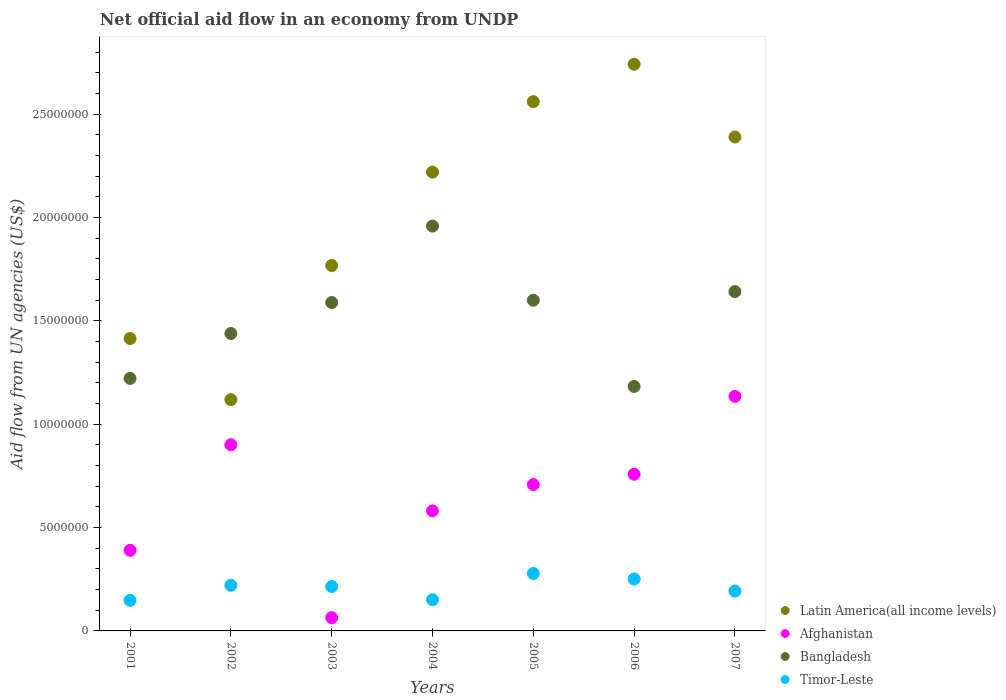What is the net official aid flow in Bangladesh in 2004?
Give a very brief answer. 1.96e+07. Across all years, what is the maximum net official aid flow in Timor-Leste?
Give a very brief answer. 2.78e+06. Across all years, what is the minimum net official aid flow in Latin America(all income levels)?
Your answer should be compact. 1.12e+07. In which year was the net official aid flow in Timor-Leste maximum?
Offer a very short reply. 2005. What is the total net official aid flow in Timor-Leste in the graph?
Provide a succinct answer. 1.46e+07. What is the difference between the net official aid flow in Bangladesh in 2005 and that in 2006?
Keep it short and to the point. 4.17e+06. What is the difference between the net official aid flow in Afghanistan in 2006 and the net official aid flow in Bangladesh in 2004?
Give a very brief answer. -1.20e+07. What is the average net official aid flow in Bangladesh per year?
Offer a very short reply. 1.52e+07. In the year 2006, what is the difference between the net official aid flow in Latin America(all income levels) and net official aid flow in Afghanistan?
Provide a succinct answer. 1.98e+07. In how many years, is the net official aid flow in Bangladesh greater than 21000000 US$?
Your answer should be compact. 0. What is the ratio of the net official aid flow in Afghanistan in 2001 to that in 2003?
Your answer should be very brief. 6.09. What is the difference between the highest and the second highest net official aid flow in Latin America(all income levels)?
Give a very brief answer. 1.81e+06. What is the difference between the highest and the lowest net official aid flow in Afghanistan?
Offer a very short reply. 1.07e+07. In how many years, is the net official aid flow in Timor-Leste greater than the average net official aid flow in Timor-Leste taken over all years?
Give a very brief answer. 4. Is it the case that in every year, the sum of the net official aid flow in Bangladesh and net official aid flow in Timor-Leste  is greater than the sum of net official aid flow in Afghanistan and net official aid flow in Latin America(all income levels)?
Your response must be concise. Yes. Is it the case that in every year, the sum of the net official aid flow in Bangladesh and net official aid flow in Timor-Leste  is greater than the net official aid flow in Afghanistan?
Ensure brevity in your answer.  Yes. Does the net official aid flow in Afghanistan monotonically increase over the years?
Offer a very short reply. No. How many years are there in the graph?
Provide a short and direct response. 7. What is the difference between two consecutive major ticks on the Y-axis?
Your answer should be very brief. 5.00e+06. Are the values on the major ticks of Y-axis written in scientific E-notation?
Provide a succinct answer. No. Where does the legend appear in the graph?
Your response must be concise. Bottom right. What is the title of the graph?
Your answer should be compact. Net official aid flow in an economy from UNDP. What is the label or title of the X-axis?
Make the answer very short. Years. What is the label or title of the Y-axis?
Make the answer very short. Aid flow from UN agencies (US$). What is the Aid flow from UN agencies (US$) of Latin America(all income levels) in 2001?
Ensure brevity in your answer.  1.42e+07. What is the Aid flow from UN agencies (US$) in Afghanistan in 2001?
Provide a short and direct response. 3.90e+06. What is the Aid flow from UN agencies (US$) in Bangladesh in 2001?
Keep it short and to the point. 1.22e+07. What is the Aid flow from UN agencies (US$) in Timor-Leste in 2001?
Offer a terse response. 1.48e+06. What is the Aid flow from UN agencies (US$) in Latin America(all income levels) in 2002?
Your answer should be compact. 1.12e+07. What is the Aid flow from UN agencies (US$) of Afghanistan in 2002?
Ensure brevity in your answer.  9.01e+06. What is the Aid flow from UN agencies (US$) in Bangladesh in 2002?
Your response must be concise. 1.44e+07. What is the Aid flow from UN agencies (US$) of Timor-Leste in 2002?
Ensure brevity in your answer.  2.21e+06. What is the Aid flow from UN agencies (US$) in Latin America(all income levels) in 2003?
Your response must be concise. 1.77e+07. What is the Aid flow from UN agencies (US$) of Afghanistan in 2003?
Give a very brief answer. 6.40e+05. What is the Aid flow from UN agencies (US$) of Bangladesh in 2003?
Provide a short and direct response. 1.59e+07. What is the Aid flow from UN agencies (US$) of Timor-Leste in 2003?
Provide a short and direct response. 2.15e+06. What is the Aid flow from UN agencies (US$) of Latin America(all income levels) in 2004?
Your answer should be very brief. 2.22e+07. What is the Aid flow from UN agencies (US$) in Afghanistan in 2004?
Offer a terse response. 5.81e+06. What is the Aid flow from UN agencies (US$) of Bangladesh in 2004?
Your answer should be very brief. 1.96e+07. What is the Aid flow from UN agencies (US$) in Timor-Leste in 2004?
Give a very brief answer. 1.51e+06. What is the Aid flow from UN agencies (US$) of Latin America(all income levels) in 2005?
Offer a very short reply. 2.56e+07. What is the Aid flow from UN agencies (US$) in Afghanistan in 2005?
Your response must be concise. 7.08e+06. What is the Aid flow from UN agencies (US$) of Bangladesh in 2005?
Provide a short and direct response. 1.60e+07. What is the Aid flow from UN agencies (US$) of Timor-Leste in 2005?
Your answer should be compact. 2.78e+06. What is the Aid flow from UN agencies (US$) of Latin America(all income levels) in 2006?
Offer a terse response. 2.74e+07. What is the Aid flow from UN agencies (US$) in Afghanistan in 2006?
Keep it short and to the point. 7.58e+06. What is the Aid flow from UN agencies (US$) of Bangladesh in 2006?
Make the answer very short. 1.18e+07. What is the Aid flow from UN agencies (US$) in Timor-Leste in 2006?
Your answer should be compact. 2.51e+06. What is the Aid flow from UN agencies (US$) of Latin America(all income levels) in 2007?
Your response must be concise. 2.39e+07. What is the Aid flow from UN agencies (US$) of Afghanistan in 2007?
Your response must be concise. 1.14e+07. What is the Aid flow from UN agencies (US$) in Bangladesh in 2007?
Offer a very short reply. 1.64e+07. What is the Aid flow from UN agencies (US$) in Timor-Leste in 2007?
Make the answer very short. 1.93e+06. Across all years, what is the maximum Aid flow from UN agencies (US$) of Latin America(all income levels)?
Offer a very short reply. 2.74e+07. Across all years, what is the maximum Aid flow from UN agencies (US$) in Afghanistan?
Give a very brief answer. 1.14e+07. Across all years, what is the maximum Aid flow from UN agencies (US$) in Bangladesh?
Make the answer very short. 1.96e+07. Across all years, what is the maximum Aid flow from UN agencies (US$) in Timor-Leste?
Your answer should be very brief. 2.78e+06. Across all years, what is the minimum Aid flow from UN agencies (US$) in Latin America(all income levels)?
Provide a short and direct response. 1.12e+07. Across all years, what is the minimum Aid flow from UN agencies (US$) of Afghanistan?
Your answer should be very brief. 6.40e+05. Across all years, what is the minimum Aid flow from UN agencies (US$) in Bangladesh?
Offer a terse response. 1.18e+07. Across all years, what is the minimum Aid flow from UN agencies (US$) of Timor-Leste?
Give a very brief answer. 1.48e+06. What is the total Aid flow from UN agencies (US$) in Latin America(all income levels) in the graph?
Ensure brevity in your answer.  1.42e+08. What is the total Aid flow from UN agencies (US$) in Afghanistan in the graph?
Make the answer very short. 4.54e+07. What is the total Aid flow from UN agencies (US$) of Bangladesh in the graph?
Your answer should be very brief. 1.06e+08. What is the total Aid flow from UN agencies (US$) in Timor-Leste in the graph?
Your answer should be compact. 1.46e+07. What is the difference between the Aid flow from UN agencies (US$) of Latin America(all income levels) in 2001 and that in 2002?
Ensure brevity in your answer.  2.96e+06. What is the difference between the Aid flow from UN agencies (US$) of Afghanistan in 2001 and that in 2002?
Keep it short and to the point. -5.11e+06. What is the difference between the Aid flow from UN agencies (US$) in Bangladesh in 2001 and that in 2002?
Provide a short and direct response. -2.17e+06. What is the difference between the Aid flow from UN agencies (US$) of Timor-Leste in 2001 and that in 2002?
Provide a short and direct response. -7.30e+05. What is the difference between the Aid flow from UN agencies (US$) of Latin America(all income levels) in 2001 and that in 2003?
Your answer should be very brief. -3.53e+06. What is the difference between the Aid flow from UN agencies (US$) in Afghanistan in 2001 and that in 2003?
Ensure brevity in your answer.  3.26e+06. What is the difference between the Aid flow from UN agencies (US$) in Bangladesh in 2001 and that in 2003?
Offer a terse response. -3.67e+06. What is the difference between the Aid flow from UN agencies (US$) of Timor-Leste in 2001 and that in 2003?
Your answer should be compact. -6.70e+05. What is the difference between the Aid flow from UN agencies (US$) of Latin America(all income levels) in 2001 and that in 2004?
Your response must be concise. -8.05e+06. What is the difference between the Aid flow from UN agencies (US$) in Afghanistan in 2001 and that in 2004?
Provide a succinct answer. -1.91e+06. What is the difference between the Aid flow from UN agencies (US$) in Bangladesh in 2001 and that in 2004?
Your response must be concise. -7.37e+06. What is the difference between the Aid flow from UN agencies (US$) of Latin America(all income levels) in 2001 and that in 2005?
Make the answer very short. -1.15e+07. What is the difference between the Aid flow from UN agencies (US$) in Afghanistan in 2001 and that in 2005?
Make the answer very short. -3.18e+06. What is the difference between the Aid flow from UN agencies (US$) in Bangladesh in 2001 and that in 2005?
Your response must be concise. -3.78e+06. What is the difference between the Aid flow from UN agencies (US$) of Timor-Leste in 2001 and that in 2005?
Provide a succinct answer. -1.30e+06. What is the difference between the Aid flow from UN agencies (US$) in Latin America(all income levels) in 2001 and that in 2006?
Provide a short and direct response. -1.33e+07. What is the difference between the Aid flow from UN agencies (US$) of Afghanistan in 2001 and that in 2006?
Your answer should be compact. -3.68e+06. What is the difference between the Aid flow from UN agencies (US$) of Bangladesh in 2001 and that in 2006?
Offer a terse response. 3.90e+05. What is the difference between the Aid flow from UN agencies (US$) of Timor-Leste in 2001 and that in 2006?
Ensure brevity in your answer.  -1.03e+06. What is the difference between the Aid flow from UN agencies (US$) of Latin America(all income levels) in 2001 and that in 2007?
Your answer should be very brief. -9.75e+06. What is the difference between the Aid flow from UN agencies (US$) in Afghanistan in 2001 and that in 2007?
Provide a succinct answer. -7.45e+06. What is the difference between the Aid flow from UN agencies (US$) of Bangladesh in 2001 and that in 2007?
Ensure brevity in your answer.  -4.20e+06. What is the difference between the Aid flow from UN agencies (US$) in Timor-Leste in 2001 and that in 2007?
Make the answer very short. -4.50e+05. What is the difference between the Aid flow from UN agencies (US$) in Latin America(all income levels) in 2002 and that in 2003?
Make the answer very short. -6.49e+06. What is the difference between the Aid flow from UN agencies (US$) in Afghanistan in 2002 and that in 2003?
Your answer should be very brief. 8.37e+06. What is the difference between the Aid flow from UN agencies (US$) in Bangladesh in 2002 and that in 2003?
Provide a succinct answer. -1.50e+06. What is the difference between the Aid flow from UN agencies (US$) of Timor-Leste in 2002 and that in 2003?
Your response must be concise. 6.00e+04. What is the difference between the Aid flow from UN agencies (US$) in Latin America(all income levels) in 2002 and that in 2004?
Give a very brief answer. -1.10e+07. What is the difference between the Aid flow from UN agencies (US$) in Afghanistan in 2002 and that in 2004?
Offer a very short reply. 3.20e+06. What is the difference between the Aid flow from UN agencies (US$) in Bangladesh in 2002 and that in 2004?
Provide a short and direct response. -5.20e+06. What is the difference between the Aid flow from UN agencies (US$) in Timor-Leste in 2002 and that in 2004?
Keep it short and to the point. 7.00e+05. What is the difference between the Aid flow from UN agencies (US$) in Latin America(all income levels) in 2002 and that in 2005?
Provide a short and direct response. -1.44e+07. What is the difference between the Aid flow from UN agencies (US$) of Afghanistan in 2002 and that in 2005?
Provide a succinct answer. 1.93e+06. What is the difference between the Aid flow from UN agencies (US$) of Bangladesh in 2002 and that in 2005?
Ensure brevity in your answer.  -1.61e+06. What is the difference between the Aid flow from UN agencies (US$) of Timor-Leste in 2002 and that in 2005?
Provide a short and direct response. -5.70e+05. What is the difference between the Aid flow from UN agencies (US$) of Latin America(all income levels) in 2002 and that in 2006?
Make the answer very short. -1.62e+07. What is the difference between the Aid flow from UN agencies (US$) in Afghanistan in 2002 and that in 2006?
Offer a terse response. 1.43e+06. What is the difference between the Aid flow from UN agencies (US$) of Bangladesh in 2002 and that in 2006?
Give a very brief answer. 2.56e+06. What is the difference between the Aid flow from UN agencies (US$) in Timor-Leste in 2002 and that in 2006?
Your answer should be compact. -3.00e+05. What is the difference between the Aid flow from UN agencies (US$) in Latin America(all income levels) in 2002 and that in 2007?
Provide a succinct answer. -1.27e+07. What is the difference between the Aid flow from UN agencies (US$) of Afghanistan in 2002 and that in 2007?
Keep it short and to the point. -2.34e+06. What is the difference between the Aid flow from UN agencies (US$) in Bangladesh in 2002 and that in 2007?
Provide a short and direct response. -2.03e+06. What is the difference between the Aid flow from UN agencies (US$) of Timor-Leste in 2002 and that in 2007?
Give a very brief answer. 2.80e+05. What is the difference between the Aid flow from UN agencies (US$) in Latin America(all income levels) in 2003 and that in 2004?
Provide a short and direct response. -4.52e+06. What is the difference between the Aid flow from UN agencies (US$) of Afghanistan in 2003 and that in 2004?
Offer a terse response. -5.17e+06. What is the difference between the Aid flow from UN agencies (US$) of Bangladesh in 2003 and that in 2004?
Your response must be concise. -3.70e+06. What is the difference between the Aid flow from UN agencies (US$) in Timor-Leste in 2003 and that in 2004?
Give a very brief answer. 6.40e+05. What is the difference between the Aid flow from UN agencies (US$) in Latin America(all income levels) in 2003 and that in 2005?
Offer a very short reply. -7.93e+06. What is the difference between the Aid flow from UN agencies (US$) of Afghanistan in 2003 and that in 2005?
Your answer should be compact. -6.44e+06. What is the difference between the Aid flow from UN agencies (US$) in Timor-Leste in 2003 and that in 2005?
Your answer should be compact. -6.30e+05. What is the difference between the Aid flow from UN agencies (US$) in Latin America(all income levels) in 2003 and that in 2006?
Give a very brief answer. -9.74e+06. What is the difference between the Aid flow from UN agencies (US$) in Afghanistan in 2003 and that in 2006?
Your answer should be compact. -6.94e+06. What is the difference between the Aid flow from UN agencies (US$) of Bangladesh in 2003 and that in 2006?
Provide a short and direct response. 4.06e+06. What is the difference between the Aid flow from UN agencies (US$) in Timor-Leste in 2003 and that in 2006?
Offer a terse response. -3.60e+05. What is the difference between the Aid flow from UN agencies (US$) of Latin America(all income levels) in 2003 and that in 2007?
Provide a succinct answer. -6.22e+06. What is the difference between the Aid flow from UN agencies (US$) in Afghanistan in 2003 and that in 2007?
Ensure brevity in your answer.  -1.07e+07. What is the difference between the Aid flow from UN agencies (US$) of Bangladesh in 2003 and that in 2007?
Provide a succinct answer. -5.30e+05. What is the difference between the Aid flow from UN agencies (US$) in Timor-Leste in 2003 and that in 2007?
Provide a short and direct response. 2.20e+05. What is the difference between the Aid flow from UN agencies (US$) of Latin America(all income levels) in 2004 and that in 2005?
Your answer should be compact. -3.41e+06. What is the difference between the Aid flow from UN agencies (US$) in Afghanistan in 2004 and that in 2005?
Provide a succinct answer. -1.27e+06. What is the difference between the Aid flow from UN agencies (US$) in Bangladesh in 2004 and that in 2005?
Give a very brief answer. 3.59e+06. What is the difference between the Aid flow from UN agencies (US$) in Timor-Leste in 2004 and that in 2005?
Keep it short and to the point. -1.27e+06. What is the difference between the Aid flow from UN agencies (US$) in Latin America(all income levels) in 2004 and that in 2006?
Ensure brevity in your answer.  -5.22e+06. What is the difference between the Aid flow from UN agencies (US$) of Afghanistan in 2004 and that in 2006?
Ensure brevity in your answer.  -1.77e+06. What is the difference between the Aid flow from UN agencies (US$) in Bangladesh in 2004 and that in 2006?
Your answer should be very brief. 7.76e+06. What is the difference between the Aid flow from UN agencies (US$) of Latin America(all income levels) in 2004 and that in 2007?
Give a very brief answer. -1.70e+06. What is the difference between the Aid flow from UN agencies (US$) in Afghanistan in 2004 and that in 2007?
Provide a succinct answer. -5.54e+06. What is the difference between the Aid flow from UN agencies (US$) of Bangladesh in 2004 and that in 2007?
Your answer should be very brief. 3.17e+06. What is the difference between the Aid flow from UN agencies (US$) in Timor-Leste in 2004 and that in 2007?
Give a very brief answer. -4.20e+05. What is the difference between the Aid flow from UN agencies (US$) in Latin America(all income levels) in 2005 and that in 2006?
Your answer should be very brief. -1.81e+06. What is the difference between the Aid flow from UN agencies (US$) in Afghanistan in 2005 and that in 2006?
Your response must be concise. -5.00e+05. What is the difference between the Aid flow from UN agencies (US$) in Bangladesh in 2005 and that in 2006?
Provide a succinct answer. 4.17e+06. What is the difference between the Aid flow from UN agencies (US$) of Timor-Leste in 2005 and that in 2006?
Your answer should be very brief. 2.70e+05. What is the difference between the Aid flow from UN agencies (US$) in Latin America(all income levels) in 2005 and that in 2007?
Your response must be concise. 1.71e+06. What is the difference between the Aid flow from UN agencies (US$) in Afghanistan in 2005 and that in 2007?
Offer a very short reply. -4.27e+06. What is the difference between the Aid flow from UN agencies (US$) of Bangladesh in 2005 and that in 2007?
Ensure brevity in your answer.  -4.20e+05. What is the difference between the Aid flow from UN agencies (US$) of Timor-Leste in 2005 and that in 2007?
Make the answer very short. 8.50e+05. What is the difference between the Aid flow from UN agencies (US$) in Latin America(all income levels) in 2006 and that in 2007?
Offer a very short reply. 3.52e+06. What is the difference between the Aid flow from UN agencies (US$) of Afghanistan in 2006 and that in 2007?
Your answer should be compact. -3.77e+06. What is the difference between the Aid flow from UN agencies (US$) in Bangladesh in 2006 and that in 2007?
Give a very brief answer. -4.59e+06. What is the difference between the Aid flow from UN agencies (US$) of Timor-Leste in 2006 and that in 2007?
Ensure brevity in your answer.  5.80e+05. What is the difference between the Aid flow from UN agencies (US$) in Latin America(all income levels) in 2001 and the Aid flow from UN agencies (US$) in Afghanistan in 2002?
Your answer should be very brief. 5.14e+06. What is the difference between the Aid flow from UN agencies (US$) in Latin America(all income levels) in 2001 and the Aid flow from UN agencies (US$) in Timor-Leste in 2002?
Your answer should be compact. 1.19e+07. What is the difference between the Aid flow from UN agencies (US$) of Afghanistan in 2001 and the Aid flow from UN agencies (US$) of Bangladesh in 2002?
Ensure brevity in your answer.  -1.05e+07. What is the difference between the Aid flow from UN agencies (US$) of Afghanistan in 2001 and the Aid flow from UN agencies (US$) of Timor-Leste in 2002?
Your answer should be very brief. 1.69e+06. What is the difference between the Aid flow from UN agencies (US$) of Bangladesh in 2001 and the Aid flow from UN agencies (US$) of Timor-Leste in 2002?
Your answer should be very brief. 1.00e+07. What is the difference between the Aid flow from UN agencies (US$) in Latin America(all income levels) in 2001 and the Aid flow from UN agencies (US$) in Afghanistan in 2003?
Keep it short and to the point. 1.35e+07. What is the difference between the Aid flow from UN agencies (US$) in Latin America(all income levels) in 2001 and the Aid flow from UN agencies (US$) in Bangladesh in 2003?
Offer a terse response. -1.74e+06. What is the difference between the Aid flow from UN agencies (US$) in Latin America(all income levels) in 2001 and the Aid flow from UN agencies (US$) in Timor-Leste in 2003?
Provide a short and direct response. 1.20e+07. What is the difference between the Aid flow from UN agencies (US$) in Afghanistan in 2001 and the Aid flow from UN agencies (US$) in Bangladesh in 2003?
Provide a succinct answer. -1.20e+07. What is the difference between the Aid flow from UN agencies (US$) in Afghanistan in 2001 and the Aid flow from UN agencies (US$) in Timor-Leste in 2003?
Your answer should be compact. 1.75e+06. What is the difference between the Aid flow from UN agencies (US$) in Bangladesh in 2001 and the Aid flow from UN agencies (US$) in Timor-Leste in 2003?
Your response must be concise. 1.01e+07. What is the difference between the Aid flow from UN agencies (US$) in Latin America(all income levels) in 2001 and the Aid flow from UN agencies (US$) in Afghanistan in 2004?
Provide a short and direct response. 8.34e+06. What is the difference between the Aid flow from UN agencies (US$) in Latin America(all income levels) in 2001 and the Aid flow from UN agencies (US$) in Bangladesh in 2004?
Offer a terse response. -5.44e+06. What is the difference between the Aid flow from UN agencies (US$) in Latin America(all income levels) in 2001 and the Aid flow from UN agencies (US$) in Timor-Leste in 2004?
Provide a short and direct response. 1.26e+07. What is the difference between the Aid flow from UN agencies (US$) of Afghanistan in 2001 and the Aid flow from UN agencies (US$) of Bangladesh in 2004?
Your answer should be compact. -1.57e+07. What is the difference between the Aid flow from UN agencies (US$) in Afghanistan in 2001 and the Aid flow from UN agencies (US$) in Timor-Leste in 2004?
Your answer should be very brief. 2.39e+06. What is the difference between the Aid flow from UN agencies (US$) of Bangladesh in 2001 and the Aid flow from UN agencies (US$) of Timor-Leste in 2004?
Your answer should be very brief. 1.07e+07. What is the difference between the Aid flow from UN agencies (US$) in Latin America(all income levels) in 2001 and the Aid flow from UN agencies (US$) in Afghanistan in 2005?
Your response must be concise. 7.07e+06. What is the difference between the Aid flow from UN agencies (US$) of Latin America(all income levels) in 2001 and the Aid flow from UN agencies (US$) of Bangladesh in 2005?
Your answer should be very brief. -1.85e+06. What is the difference between the Aid flow from UN agencies (US$) in Latin America(all income levels) in 2001 and the Aid flow from UN agencies (US$) in Timor-Leste in 2005?
Your answer should be compact. 1.14e+07. What is the difference between the Aid flow from UN agencies (US$) of Afghanistan in 2001 and the Aid flow from UN agencies (US$) of Bangladesh in 2005?
Your answer should be compact. -1.21e+07. What is the difference between the Aid flow from UN agencies (US$) in Afghanistan in 2001 and the Aid flow from UN agencies (US$) in Timor-Leste in 2005?
Keep it short and to the point. 1.12e+06. What is the difference between the Aid flow from UN agencies (US$) of Bangladesh in 2001 and the Aid flow from UN agencies (US$) of Timor-Leste in 2005?
Provide a short and direct response. 9.44e+06. What is the difference between the Aid flow from UN agencies (US$) of Latin America(all income levels) in 2001 and the Aid flow from UN agencies (US$) of Afghanistan in 2006?
Ensure brevity in your answer.  6.57e+06. What is the difference between the Aid flow from UN agencies (US$) of Latin America(all income levels) in 2001 and the Aid flow from UN agencies (US$) of Bangladesh in 2006?
Your answer should be compact. 2.32e+06. What is the difference between the Aid flow from UN agencies (US$) of Latin America(all income levels) in 2001 and the Aid flow from UN agencies (US$) of Timor-Leste in 2006?
Ensure brevity in your answer.  1.16e+07. What is the difference between the Aid flow from UN agencies (US$) of Afghanistan in 2001 and the Aid flow from UN agencies (US$) of Bangladesh in 2006?
Provide a short and direct response. -7.93e+06. What is the difference between the Aid flow from UN agencies (US$) of Afghanistan in 2001 and the Aid flow from UN agencies (US$) of Timor-Leste in 2006?
Your answer should be very brief. 1.39e+06. What is the difference between the Aid flow from UN agencies (US$) of Bangladesh in 2001 and the Aid flow from UN agencies (US$) of Timor-Leste in 2006?
Provide a succinct answer. 9.71e+06. What is the difference between the Aid flow from UN agencies (US$) in Latin America(all income levels) in 2001 and the Aid flow from UN agencies (US$) in Afghanistan in 2007?
Provide a succinct answer. 2.80e+06. What is the difference between the Aid flow from UN agencies (US$) of Latin America(all income levels) in 2001 and the Aid flow from UN agencies (US$) of Bangladesh in 2007?
Your answer should be compact. -2.27e+06. What is the difference between the Aid flow from UN agencies (US$) in Latin America(all income levels) in 2001 and the Aid flow from UN agencies (US$) in Timor-Leste in 2007?
Keep it short and to the point. 1.22e+07. What is the difference between the Aid flow from UN agencies (US$) of Afghanistan in 2001 and the Aid flow from UN agencies (US$) of Bangladesh in 2007?
Keep it short and to the point. -1.25e+07. What is the difference between the Aid flow from UN agencies (US$) of Afghanistan in 2001 and the Aid flow from UN agencies (US$) of Timor-Leste in 2007?
Your response must be concise. 1.97e+06. What is the difference between the Aid flow from UN agencies (US$) in Bangladesh in 2001 and the Aid flow from UN agencies (US$) in Timor-Leste in 2007?
Ensure brevity in your answer.  1.03e+07. What is the difference between the Aid flow from UN agencies (US$) in Latin America(all income levels) in 2002 and the Aid flow from UN agencies (US$) in Afghanistan in 2003?
Offer a terse response. 1.06e+07. What is the difference between the Aid flow from UN agencies (US$) of Latin America(all income levels) in 2002 and the Aid flow from UN agencies (US$) of Bangladesh in 2003?
Ensure brevity in your answer.  -4.70e+06. What is the difference between the Aid flow from UN agencies (US$) in Latin America(all income levels) in 2002 and the Aid flow from UN agencies (US$) in Timor-Leste in 2003?
Give a very brief answer. 9.04e+06. What is the difference between the Aid flow from UN agencies (US$) of Afghanistan in 2002 and the Aid flow from UN agencies (US$) of Bangladesh in 2003?
Keep it short and to the point. -6.88e+06. What is the difference between the Aid flow from UN agencies (US$) in Afghanistan in 2002 and the Aid flow from UN agencies (US$) in Timor-Leste in 2003?
Your answer should be compact. 6.86e+06. What is the difference between the Aid flow from UN agencies (US$) in Bangladesh in 2002 and the Aid flow from UN agencies (US$) in Timor-Leste in 2003?
Ensure brevity in your answer.  1.22e+07. What is the difference between the Aid flow from UN agencies (US$) of Latin America(all income levels) in 2002 and the Aid flow from UN agencies (US$) of Afghanistan in 2004?
Provide a succinct answer. 5.38e+06. What is the difference between the Aid flow from UN agencies (US$) in Latin America(all income levels) in 2002 and the Aid flow from UN agencies (US$) in Bangladesh in 2004?
Keep it short and to the point. -8.40e+06. What is the difference between the Aid flow from UN agencies (US$) of Latin America(all income levels) in 2002 and the Aid flow from UN agencies (US$) of Timor-Leste in 2004?
Make the answer very short. 9.68e+06. What is the difference between the Aid flow from UN agencies (US$) of Afghanistan in 2002 and the Aid flow from UN agencies (US$) of Bangladesh in 2004?
Ensure brevity in your answer.  -1.06e+07. What is the difference between the Aid flow from UN agencies (US$) of Afghanistan in 2002 and the Aid flow from UN agencies (US$) of Timor-Leste in 2004?
Offer a very short reply. 7.50e+06. What is the difference between the Aid flow from UN agencies (US$) in Bangladesh in 2002 and the Aid flow from UN agencies (US$) in Timor-Leste in 2004?
Ensure brevity in your answer.  1.29e+07. What is the difference between the Aid flow from UN agencies (US$) of Latin America(all income levels) in 2002 and the Aid flow from UN agencies (US$) of Afghanistan in 2005?
Ensure brevity in your answer.  4.11e+06. What is the difference between the Aid flow from UN agencies (US$) of Latin America(all income levels) in 2002 and the Aid flow from UN agencies (US$) of Bangladesh in 2005?
Provide a succinct answer. -4.81e+06. What is the difference between the Aid flow from UN agencies (US$) of Latin America(all income levels) in 2002 and the Aid flow from UN agencies (US$) of Timor-Leste in 2005?
Give a very brief answer. 8.41e+06. What is the difference between the Aid flow from UN agencies (US$) in Afghanistan in 2002 and the Aid flow from UN agencies (US$) in Bangladesh in 2005?
Your answer should be very brief. -6.99e+06. What is the difference between the Aid flow from UN agencies (US$) of Afghanistan in 2002 and the Aid flow from UN agencies (US$) of Timor-Leste in 2005?
Offer a very short reply. 6.23e+06. What is the difference between the Aid flow from UN agencies (US$) in Bangladesh in 2002 and the Aid flow from UN agencies (US$) in Timor-Leste in 2005?
Provide a short and direct response. 1.16e+07. What is the difference between the Aid flow from UN agencies (US$) in Latin America(all income levels) in 2002 and the Aid flow from UN agencies (US$) in Afghanistan in 2006?
Your answer should be very brief. 3.61e+06. What is the difference between the Aid flow from UN agencies (US$) in Latin America(all income levels) in 2002 and the Aid flow from UN agencies (US$) in Bangladesh in 2006?
Provide a short and direct response. -6.40e+05. What is the difference between the Aid flow from UN agencies (US$) in Latin America(all income levels) in 2002 and the Aid flow from UN agencies (US$) in Timor-Leste in 2006?
Your answer should be very brief. 8.68e+06. What is the difference between the Aid flow from UN agencies (US$) in Afghanistan in 2002 and the Aid flow from UN agencies (US$) in Bangladesh in 2006?
Give a very brief answer. -2.82e+06. What is the difference between the Aid flow from UN agencies (US$) of Afghanistan in 2002 and the Aid flow from UN agencies (US$) of Timor-Leste in 2006?
Your answer should be compact. 6.50e+06. What is the difference between the Aid flow from UN agencies (US$) of Bangladesh in 2002 and the Aid flow from UN agencies (US$) of Timor-Leste in 2006?
Offer a very short reply. 1.19e+07. What is the difference between the Aid flow from UN agencies (US$) of Latin America(all income levels) in 2002 and the Aid flow from UN agencies (US$) of Bangladesh in 2007?
Keep it short and to the point. -5.23e+06. What is the difference between the Aid flow from UN agencies (US$) of Latin America(all income levels) in 2002 and the Aid flow from UN agencies (US$) of Timor-Leste in 2007?
Provide a succinct answer. 9.26e+06. What is the difference between the Aid flow from UN agencies (US$) in Afghanistan in 2002 and the Aid flow from UN agencies (US$) in Bangladesh in 2007?
Provide a succinct answer. -7.41e+06. What is the difference between the Aid flow from UN agencies (US$) of Afghanistan in 2002 and the Aid flow from UN agencies (US$) of Timor-Leste in 2007?
Offer a terse response. 7.08e+06. What is the difference between the Aid flow from UN agencies (US$) of Bangladesh in 2002 and the Aid flow from UN agencies (US$) of Timor-Leste in 2007?
Your response must be concise. 1.25e+07. What is the difference between the Aid flow from UN agencies (US$) of Latin America(all income levels) in 2003 and the Aid flow from UN agencies (US$) of Afghanistan in 2004?
Make the answer very short. 1.19e+07. What is the difference between the Aid flow from UN agencies (US$) of Latin America(all income levels) in 2003 and the Aid flow from UN agencies (US$) of Bangladesh in 2004?
Offer a terse response. -1.91e+06. What is the difference between the Aid flow from UN agencies (US$) of Latin America(all income levels) in 2003 and the Aid flow from UN agencies (US$) of Timor-Leste in 2004?
Provide a succinct answer. 1.62e+07. What is the difference between the Aid flow from UN agencies (US$) in Afghanistan in 2003 and the Aid flow from UN agencies (US$) in Bangladesh in 2004?
Your answer should be very brief. -1.90e+07. What is the difference between the Aid flow from UN agencies (US$) of Afghanistan in 2003 and the Aid flow from UN agencies (US$) of Timor-Leste in 2004?
Make the answer very short. -8.70e+05. What is the difference between the Aid flow from UN agencies (US$) in Bangladesh in 2003 and the Aid flow from UN agencies (US$) in Timor-Leste in 2004?
Offer a very short reply. 1.44e+07. What is the difference between the Aid flow from UN agencies (US$) in Latin America(all income levels) in 2003 and the Aid flow from UN agencies (US$) in Afghanistan in 2005?
Offer a terse response. 1.06e+07. What is the difference between the Aid flow from UN agencies (US$) in Latin America(all income levels) in 2003 and the Aid flow from UN agencies (US$) in Bangladesh in 2005?
Make the answer very short. 1.68e+06. What is the difference between the Aid flow from UN agencies (US$) of Latin America(all income levels) in 2003 and the Aid flow from UN agencies (US$) of Timor-Leste in 2005?
Your answer should be compact. 1.49e+07. What is the difference between the Aid flow from UN agencies (US$) of Afghanistan in 2003 and the Aid flow from UN agencies (US$) of Bangladesh in 2005?
Offer a terse response. -1.54e+07. What is the difference between the Aid flow from UN agencies (US$) in Afghanistan in 2003 and the Aid flow from UN agencies (US$) in Timor-Leste in 2005?
Provide a succinct answer. -2.14e+06. What is the difference between the Aid flow from UN agencies (US$) of Bangladesh in 2003 and the Aid flow from UN agencies (US$) of Timor-Leste in 2005?
Provide a succinct answer. 1.31e+07. What is the difference between the Aid flow from UN agencies (US$) in Latin America(all income levels) in 2003 and the Aid flow from UN agencies (US$) in Afghanistan in 2006?
Offer a very short reply. 1.01e+07. What is the difference between the Aid flow from UN agencies (US$) in Latin America(all income levels) in 2003 and the Aid flow from UN agencies (US$) in Bangladesh in 2006?
Make the answer very short. 5.85e+06. What is the difference between the Aid flow from UN agencies (US$) of Latin America(all income levels) in 2003 and the Aid flow from UN agencies (US$) of Timor-Leste in 2006?
Ensure brevity in your answer.  1.52e+07. What is the difference between the Aid flow from UN agencies (US$) of Afghanistan in 2003 and the Aid flow from UN agencies (US$) of Bangladesh in 2006?
Keep it short and to the point. -1.12e+07. What is the difference between the Aid flow from UN agencies (US$) in Afghanistan in 2003 and the Aid flow from UN agencies (US$) in Timor-Leste in 2006?
Ensure brevity in your answer.  -1.87e+06. What is the difference between the Aid flow from UN agencies (US$) in Bangladesh in 2003 and the Aid flow from UN agencies (US$) in Timor-Leste in 2006?
Your answer should be compact. 1.34e+07. What is the difference between the Aid flow from UN agencies (US$) in Latin America(all income levels) in 2003 and the Aid flow from UN agencies (US$) in Afghanistan in 2007?
Provide a succinct answer. 6.33e+06. What is the difference between the Aid flow from UN agencies (US$) in Latin America(all income levels) in 2003 and the Aid flow from UN agencies (US$) in Bangladesh in 2007?
Provide a short and direct response. 1.26e+06. What is the difference between the Aid flow from UN agencies (US$) in Latin America(all income levels) in 2003 and the Aid flow from UN agencies (US$) in Timor-Leste in 2007?
Provide a short and direct response. 1.58e+07. What is the difference between the Aid flow from UN agencies (US$) in Afghanistan in 2003 and the Aid flow from UN agencies (US$) in Bangladesh in 2007?
Provide a short and direct response. -1.58e+07. What is the difference between the Aid flow from UN agencies (US$) of Afghanistan in 2003 and the Aid flow from UN agencies (US$) of Timor-Leste in 2007?
Make the answer very short. -1.29e+06. What is the difference between the Aid flow from UN agencies (US$) of Bangladesh in 2003 and the Aid flow from UN agencies (US$) of Timor-Leste in 2007?
Offer a terse response. 1.40e+07. What is the difference between the Aid flow from UN agencies (US$) of Latin America(all income levels) in 2004 and the Aid flow from UN agencies (US$) of Afghanistan in 2005?
Offer a very short reply. 1.51e+07. What is the difference between the Aid flow from UN agencies (US$) of Latin America(all income levels) in 2004 and the Aid flow from UN agencies (US$) of Bangladesh in 2005?
Your response must be concise. 6.20e+06. What is the difference between the Aid flow from UN agencies (US$) in Latin America(all income levels) in 2004 and the Aid flow from UN agencies (US$) in Timor-Leste in 2005?
Your response must be concise. 1.94e+07. What is the difference between the Aid flow from UN agencies (US$) of Afghanistan in 2004 and the Aid flow from UN agencies (US$) of Bangladesh in 2005?
Make the answer very short. -1.02e+07. What is the difference between the Aid flow from UN agencies (US$) in Afghanistan in 2004 and the Aid flow from UN agencies (US$) in Timor-Leste in 2005?
Your answer should be compact. 3.03e+06. What is the difference between the Aid flow from UN agencies (US$) of Bangladesh in 2004 and the Aid flow from UN agencies (US$) of Timor-Leste in 2005?
Offer a very short reply. 1.68e+07. What is the difference between the Aid flow from UN agencies (US$) in Latin America(all income levels) in 2004 and the Aid flow from UN agencies (US$) in Afghanistan in 2006?
Your response must be concise. 1.46e+07. What is the difference between the Aid flow from UN agencies (US$) in Latin America(all income levels) in 2004 and the Aid flow from UN agencies (US$) in Bangladesh in 2006?
Make the answer very short. 1.04e+07. What is the difference between the Aid flow from UN agencies (US$) in Latin America(all income levels) in 2004 and the Aid flow from UN agencies (US$) in Timor-Leste in 2006?
Provide a succinct answer. 1.97e+07. What is the difference between the Aid flow from UN agencies (US$) of Afghanistan in 2004 and the Aid flow from UN agencies (US$) of Bangladesh in 2006?
Ensure brevity in your answer.  -6.02e+06. What is the difference between the Aid flow from UN agencies (US$) in Afghanistan in 2004 and the Aid flow from UN agencies (US$) in Timor-Leste in 2006?
Keep it short and to the point. 3.30e+06. What is the difference between the Aid flow from UN agencies (US$) of Bangladesh in 2004 and the Aid flow from UN agencies (US$) of Timor-Leste in 2006?
Make the answer very short. 1.71e+07. What is the difference between the Aid flow from UN agencies (US$) of Latin America(all income levels) in 2004 and the Aid flow from UN agencies (US$) of Afghanistan in 2007?
Your answer should be very brief. 1.08e+07. What is the difference between the Aid flow from UN agencies (US$) of Latin America(all income levels) in 2004 and the Aid flow from UN agencies (US$) of Bangladesh in 2007?
Keep it short and to the point. 5.78e+06. What is the difference between the Aid flow from UN agencies (US$) of Latin America(all income levels) in 2004 and the Aid flow from UN agencies (US$) of Timor-Leste in 2007?
Offer a very short reply. 2.03e+07. What is the difference between the Aid flow from UN agencies (US$) of Afghanistan in 2004 and the Aid flow from UN agencies (US$) of Bangladesh in 2007?
Offer a terse response. -1.06e+07. What is the difference between the Aid flow from UN agencies (US$) in Afghanistan in 2004 and the Aid flow from UN agencies (US$) in Timor-Leste in 2007?
Your response must be concise. 3.88e+06. What is the difference between the Aid flow from UN agencies (US$) of Bangladesh in 2004 and the Aid flow from UN agencies (US$) of Timor-Leste in 2007?
Keep it short and to the point. 1.77e+07. What is the difference between the Aid flow from UN agencies (US$) in Latin America(all income levels) in 2005 and the Aid flow from UN agencies (US$) in Afghanistan in 2006?
Your answer should be compact. 1.80e+07. What is the difference between the Aid flow from UN agencies (US$) of Latin America(all income levels) in 2005 and the Aid flow from UN agencies (US$) of Bangladesh in 2006?
Provide a short and direct response. 1.38e+07. What is the difference between the Aid flow from UN agencies (US$) of Latin America(all income levels) in 2005 and the Aid flow from UN agencies (US$) of Timor-Leste in 2006?
Provide a short and direct response. 2.31e+07. What is the difference between the Aid flow from UN agencies (US$) in Afghanistan in 2005 and the Aid flow from UN agencies (US$) in Bangladesh in 2006?
Your response must be concise. -4.75e+06. What is the difference between the Aid flow from UN agencies (US$) in Afghanistan in 2005 and the Aid flow from UN agencies (US$) in Timor-Leste in 2006?
Your answer should be compact. 4.57e+06. What is the difference between the Aid flow from UN agencies (US$) of Bangladesh in 2005 and the Aid flow from UN agencies (US$) of Timor-Leste in 2006?
Give a very brief answer. 1.35e+07. What is the difference between the Aid flow from UN agencies (US$) of Latin America(all income levels) in 2005 and the Aid flow from UN agencies (US$) of Afghanistan in 2007?
Keep it short and to the point. 1.43e+07. What is the difference between the Aid flow from UN agencies (US$) of Latin America(all income levels) in 2005 and the Aid flow from UN agencies (US$) of Bangladesh in 2007?
Make the answer very short. 9.19e+06. What is the difference between the Aid flow from UN agencies (US$) of Latin America(all income levels) in 2005 and the Aid flow from UN agencies (US$) of Timor-Leste in 2007?
Offer a very short reply. 2.37e+07. What is the difference between the Aid flow from UN agencies (US$) in Afghanistan in 2005 and the Aid flow from UN agencies (US$) in Bangladesh in 2007?
Keep it short and to the point. -9.34e+06. What is the difference between the Aid flow from UN agencies (US$) in Afghanistan in 2005 and the Aid flow from UN agencies (US$) in Timor-Leste in 2007?
Offer a very short reply. 5.15e+06. What is the difference between the Aid flow from UN agencies (US$) of Bangladesh in 2005 and the Aid flow from UN agencies (US$) of Timor-Leste in 2007?
Make the answer very short. 1.41e+07. What is the difference between the Aid flow from UN agencies (US$) of Latin America(all income levels) in 2006 and the Aid flow from UN agencies (US$) of Afghanistan in 2007?
Make the answer very short. 1.61e+07. What is the difference between the Aid flow from UN agencies (US$) of Latin America(all income levels) in 2006 and the Aid flow from UN agencies (US$) of Bangladesh in 2007?
Give a very brief answer. 1.10e+07. What is the difference between the Aid flow from UN agencies (US$) in Latin America(all income levels) in 2006 and the Aid flow from UN agencies (US$) in Timor-Leste in 2007?
Make the answer very short. 2.55e+07. What is the difference between the Aid flow from UN agencies (US$) of Afghanistan in 2006 and the Aid flow from UN agencies (US$) of Bangladesh in 2007?
Ensure brevity in your answer.  -8.84e+06. What is the difference between the Aid flow from UN agencies (US$) in Afghanistan in 2006 and the Aid flow from UN agencies (US$) in Timor-Leste in 2007?
Your answer should be very brief. 5.65e+06. What is the difference between the Aid flow from UN agencies (US$) of Bangladesh in 2006 and the Aid flow from UN agencies (US$) of Timor-Leste in 2007?
Your response must be concise. 9.90e+06. What is the average Aid flow from UN agencies (US$) of Latin America(all income levels) per year?
Provide a short and direct response. 2.03e+07. What is the average Aid flow from UN agencies (US$) in Afghanistan per year?
Give a very brief answer. 6.48e+06. What is the average Aid flow from UN agencies (US$) in Bangladesh per year?
Offer a very short reply. 1.52e+07. What is the average Aid flow from UN agencies (US$) in Timor-Leste per year?
Offer a very short reply. 2.08e+06. In the year 2001, what is the difference between the Aid flow from UN agencies (US$) in Latin America(all income levels) and Aid flow from UN agencies (US$) in Afghanistan?
Your answer should be very brief. 1.02e+07. In the year 2001, what is the difference between the Aid flow from UN agencies (US$) of Latin America(all income levels) and Aid flow from UN agencies (US$) of Bangladesh?
Provide a succinct answer. 1.93e+06. In the year 2001, what is the difference between the Aid flow from UN agencies (US$) of Latin America(all income levels) and Aid flow from UN agencies (US$) of Timor-Leste?
Make the answer very short. 1.27e+07. In the year 2001, what is the difference between the Aid flow from UN agencies (US$) in Afghanistan and Aid flow from UN agencies (US$) in Bangladesh?
Your answer should be very brief. -8.32e+06. In the year 2001, what is the difference between the Aid flow from UN agencies (US$) in Afghanistan and Aid flow from UN agencies (US$) in Timor-Leste?
Offer a terse response. 2.42e+06. In the year 2001, what is the difference between the Aid flow from UN agencies (US$) of Bangladesh and Aid flow from UN agencies (US$) of Timor-Leste?
Provide a succinct answer. 1.07e+07. In the year 2002, what is the difference between the Aid flow from UN agencies (US$) in Latin America(all income levels) and Aid flow from UN agencies (US$) in Afghanistan?
Give a very brief answer. 2.18e+06. In the year 2002, what is the difference between the Aid flow from UN agencies (US$) of Latin America(all income levels) and Aid flow from UN agencies (US$) of Bangladesh?
Make the answer very short. -3.20e+06. In the year 2002, what is the difference between the Aid flow from UN agencies (US$) in Latin America(all income levels) and Aid flow from UN agencies (US$) in Timor-Leste?
Make the answer very short. 8.98e+06. In the year 2002, what is the difference between the Aid flow from UN agencies (US$) in Afghanistan and Aid flow from UN agencies (US$) in Bangladesh?
Provide a short and direct response. -5.38e+06. In the year 2002, what is the difference between the Aid flow from UN agencies (US$) of Afghanistan and Aid flow from UN agencies (US$) of Timor-Leste?
Your answer should be compact. 6.80e+06. In the year 2002, what is the difference between the Aid flow from UN agencies (US$) in Bangladesh and Aid flow from UN agencies (US$) in Timor-Leste?
Provide a short and direct response. 1.22e+07. In the year 2003, what is the difference between the Aid flow from UN agencies (US$) of Latin America(all income levels) and Aid flow from UN agencies (US$) of Afghanistan?
Your answer should be compact. 1.70e+07. In the year 2003, what is the difference between the Aid flow from UN agencies (US$) in Latin America(all income levels) and Aid flow from UN agencies (US$) in Bangladesh?
Keep it short and to the point. 1.79e+06. In the year 2003, what is the difference between the Aid flow from UN agencies (US$) in Latin America(all income levels) and Aid flow from UN agencies (US$) in Timor-Leste?
Your answer should be very brief. 1.55e+07. In the year 2003, what is the difference between the Aid flow from UN agencies (US$) in Afghanistan and Aid flow from UN agencies (US$) in Bangladesh?
Keep it short and to the point. -1.52e+07. In the year 2003, what is the difference between the Aid flow from UN agencies (US$) of Afghanistan and Aid flow from UN agencies (US$) of Timor-Leste?
Your answer should be very brief. -1.51e+06. In the year 2003, what is the difference between the Aid flow from UN agencies (US$) of Bangladesh and Aid flow from UN agencies (US$) of Timor-Leste?
Provide a succinct answer. 1.37e+07. In the year 2004, what is the difference between the Aid flow from UN agencies (US$) in Latin America(all income levels) and Aid flow from UN agencies (US$) in Afghanistan?
Provide a succinct answer. 1.64e+07. In the year 2004, what is the difference between the Aid flow from UN agencies (US$) in Latin America(all income levels) and Aid flow from UN agencies (US$) in Bangladesh?
Your answer should be very brief. 2.61e+06. In the year 2004, what is the difference between the Aid flow from UN agencies (US$) in Latin America(all income levels) and Aid flow from UN agencies (US$) in Timor-Leste?
Your response must be concise. 2.07e+07. In the year 2004, what is the difference between the Aid flow from UN agencies (US$) in Afghanistan and Aid flow from UN agencies (US$) in Bangladesh?
Your answer should be very brief. -1.38e+07. In the year 2004, what is the difference between the Aid flow from UN agencies (US$) of Afghanistan and Aid flow from UN agencies (US$) of Timor-Leste?
Keep it short and to the point. 4.30e+06. In the year 2004, what is the difference between the Aid flow from UN agencies (US$) in Bangladesh and Aid flow from UN agencies (US$) in Timor-Leste?
Your response must be concise. 1.81e+07. In the year 2005, what is the difference between the Aid flow from UN agencies (US$) of Latin America(all income levels) and Aid flow from UN agencies (US$) of Afghanistan?
Your answer should be very brief. 1.85e+07. In the year 2005, what is the difference between the Aid flow from UN agencies (US$) of Latin America(all income levels) and Aid flow from UN agencies (US$) of Bangladesh?
Offer a very short reply. 9.61e+06. In the year 2005, what is the difference between the Aid flow from UN agencies (US$) in Latin America(all income levels) and Aid flow from UN agencies (US$) in Timor-Leste?
Ensure brevity in your answer.  2.28e+07. In the year 2005, what is the difference between the Aid flow from UN agencies (US$) in Afghanistan and Aid flow from UN agencies (US$) in Bangladesh?
Make the answer very short. -8.92e+06. In the year 2005, what is the difference between the Aid flow from UN agencies (US$) of Afghanistan and Aid flow from UN agencies (US$) of Timor-Leste?
Provide a short and direct response. 4.30e+06. In the year 2005, what is the difference between the Aid flow from UN agencies (US$) of Bangladesh and Aid flow from UN agencies (US$) of Timor-Leste?
Offer a very short reply. 1.32e+07. In the year 2006, what is the difference between the Aid flow from UN agencies (US$) in Latin America(all income levels) and Aid flow from UN agencies (US$) in Afghanistan?
Provide a short and direct response. 1.98e+07. In the year 2006, what is the difference between the Aid flow from UN agencies (US$) in Latin America(all income levels) and Aid flow from UN agencies (US$) in Bangladesh?
Give a very brief answer. 1.56e+07. In the year 2006, what is the difference between the Aid flow from UN agencies (US$) in Latin America(all income levels) and Aid flow from UN agencies (US$) in Timor-Leste?
Your response must be concise. 2.49e+07. In the year 2006, what is the difference between the Aid flow from UN agencies (US$) of Afghanistan and Aid flow from UN agencies (US$) of Bangladesh?
Provide a short and direct response. -4.25e+06. In the year 2006, what is the difference between the Aid flow from UN agencies (US$) of Afghanistan and Aid flow from UN agencies (US$) of Timor-Leste?
Offer a very short reply. 5.07e+06. In the year 2006, what is the difference between the Aid flow from UN agencies (US$) of Bangladesh and Aid flow from UN agencies (US$) of Timor-Leste?
Keep it short and to the point. 9.32e+06. In the year 2007, what is the difference between the Aid flow from UN agencies (US$) in Latin America(all income levels) and Aid flow from UN agencies (US$) in Afghanistan?
Provide a succinct answer. 1.26e+07. In the year 2007, what is the difference between the Aid flow from UN agencies (US$) of Latin America(all income levels) and Aid flow from UN agencies (US$) of Bangladesh?
Provide a short and direct response. 7.48e+06. In the year 2007, what is the difference between the Aid flow from UN agencies (US$) of Latin America(all income levels) and Aid flow from UN agencies (US$) of Timor-Leste?
Offer a very short reply. 2.20e+07. In the year 2007, what is the difference between the Aid flow from UN agencies (US$) in Afghanistan and Aid flow from UN agencies (US$) in Bangladesh?
Ensure brevity in your answer.  -5.07e+06. In the year 2007, what is the difference between the Aid flow from UN agencies (US$) of Afghanistan and Aid flow from UN agencies (US$) of Timor-Leste?
Provide a succinct answer. 9.42e+06. In the year 2007, what is the difference between the Aid flow from UN agencies (US$) in Bangladesh and Aid flow from UN agencies (US$) in Timor-Leste?
Your answer should be compact. 1.45e+07. What is the ratio of the Aid flow from UN agencies (US$) of Latin America(all income levels) in 2001 to that in 2002?
Give a very brief answer. 1.26. What is the ratio of the Aid flow from UN agencies (US$) in Afghanistan in 2001 to that in 2002?
Give a very brief answer. 0.43. What is the ratio of the Aid flow from UN agencies (US$) of Bangladesh in 2001 to that in 2002?
Offer a very short reply. 0.85. What is the ratio of the Aid flow from UN agencies (US$) in Timor-Leste in 2001 to that in 2002?
Offer a very short reply. 0.67. What is the ratio of the Aid flow from UN agencies (US$) of Latin America(all income levels) in 2001 to that in 2003?
Ensure brevity in your answer.  0.8. What is the ratio of the Aid flow from UN agencies (US$) in Afghanistan in 2001 to that in 2003?
Offer a very short reply. 6.09. What is the ratio of the Aid flow from UN agencies (US$) in Bangladesh in 2001 to that in 2003?
Provide a succinct answer. 0.77. What is the ratio of the Aid flow from UN agencies (US$) in Timor-Leste in 2001 to that in 2003?
Provide a short and direct response. 0.69. What is the ratio of the Aid flow from UN agencies (US$) of Latin America(all income levels) in 2001 to that in 2004?
Provide a succinct answer. 0.64. What is the ratio of the Aid flow from UN agencies (US$) in Afghanistan in 2001 to that in 2004?
Offer a very short reply. 0.67. What is the ratio of the Aid flow from UN agencies (US$) in Bangladesh in 2001 to that in 2004?
Provide a succinct answer. 0.62. What is the ratio of the Aid flow from UN agencies (US$) in Timor-Leste in 2001 to that in 2004?
Provide a succinct answer. 0.98. What is the ratio of the Aid flow from UN agencies (US$) of Latin America(all income levels) in 2001 to that in 2005?
Keep it short and to the point. 0.55. What is the ratio of the Aid flow from UN agencies (US$) of Afghanistan in 2001 to that in 2005?
Your response must be concise. 0.55. What is the ratio of the Aid flow from UN agencies (US$) of Bangladesh in 2001 to that in 2005?
Provide a short and direct response. 0.76. What is the ratio of the Aid flow from UN agencies (US$) in Timor-Leste in 2001 to that in 2005?
Make the answer very short. 0.53. What is the ratio of the Aid flow from UN agencies (US$) in Latin America(all income levels) in 2001 to that in 2006?
Offer a very short reply. 0.52. What is the ratio of the Aid flow from UN agencies (US$) of Afghanistan in 2001 to that in 2006?
Ensure brevity in your answer.  0.51. What is the ratio of the Aid flow from UN agencies (US$) of Bangladesh in 2001 to that in 2006?
Offer a very short reply. 1.03. What is the ratio of the Aid flow from UN agencies (US$) of Timor-Leste in 2001 to that in 2006?
Keep it short and to the point. 0.59. What is the ratio of the Aid flow from UN agencies (US$) of Latin America(all income levels) in 2001 to that in 2007?
Offer a very short reply. 0.59. What is the ratio of the Aid flow from UN agencies (US$) of Afghanistan in 2001 to that in 2007?
Provide a short and direct response. 0.34. What is the ratio of the Aid flow from UN agencies (US$) of Bangladesh in 2001 to that in 2007?
Keep it short and to the point. 0.74. What is the ratio of the Aid flow from UN agencies (US$) in Timor-Leste in 2001 to that in 2007?
Keep it short and to the point. 0.77. What is the ratio of the Aid flow from UN agencies (US$) in Latin America(all income levels) in 2002 to that in 2003?
Make the answer very short. 0.63. What is the ratio of the Aid flow from UN agencies (US$) of Afghanistan in 2002 to that in 2003?
Provide a succinct answer. 14.08. What is the ratio of the Aid flow from UN agencies (US$) in Bangladesh in 2002 to that in 2003?
Your answer should be very brief. 0.91. What is the ratio of the Aid flow from UN agencies (US$) in Timor-Leste in 2002 to that in 2003?
Provide a succinct answer. 1.03. What is the ratio of the Aid flow from UN agencies (US$) of Latin America(all income levels) in 2002 to that in 2004?
Make the answer very short. 0.5. What is the ratio of the Aid flow from UN agencies (US$) of Afghanistan in 2002 to that in 2004?
Offer a terse response. 1.55. What is the ratio of the Aid flow from UN agencies (US$) in Bangladesh in 2002 to that in 2004?
Offer a terse response. 0.73. What is the ratio of the Aid flow from UN agencies (US$) of Timor-Leste in 2002 to that in 2004?
Offer a terse response. 1.46. What is the ratio of the Aid flow from UN agencies (US$) in Latin America(all income levels) in 2002 to that in 2005?
Keep it short and to the point. 0.44. What is the ratio of the Aid flow from UN agencies (US$) in Afghanistan in 2002 to that in 2005?
Make the answer very short. 1.27. What is the ratio of the Aid flow from UN agencies (US$) of Bangladesh in 2002 to that in 2005?
Provide a short and direct response. 0.9. What is the ratio of the Aid flow from UN agencies (US$) in Timor-Leste in 2002 to that in 2005?
Your answer should be very brief. 0.8. What is the ratio of the Aid flow from UN agencies (US$) in Latin America(all income levels) in 2002 to that in 2006?
Ensure brevity in your answer.  0.41. What is the ratio of the Aid flow from UN agencies (US$) of Afghanistan in 2002 to that in 2006?
Offer a terse response. 1.19. What is the ratio of the Aid flow from UN agencies (US$) of Bangladesh in 2002 to that in 2006?
Make the answer very short. 1.22. What is the ratio of the Aid flow from UN agencies (US$) in Timor-Leste in 2002 to that in 2006?
Offer a terse response. 0.88. What is the ratio of the Aid flow from UN agencies (US$) of Latin America(all income levels) in 2002 to that in 2007?
Provide a succinct answer. 0.47. What is the ratio of the Aid flow from UN agencies (US$) in Afghanistan in 2002 to that in 2007?
Give a very brief answer. 0.79. What is the ratio of the Aid flow from UN agencies (US$) of Bangladesh in 2002 to that in 2007?
Offer a terse response. 0.88. What is the ratio of the Aid flow from UN agencies (US$) in Timor-Leste in 2002 to that in 2007?
Give a very brief answer. 1.15. What is the ratio of the Aid flow from UN agencies (US$) of Latin America(all income levels) in 2003 to that in 2004?
Provide a short and direct response. 0.8. What is the ratio of the Aid flow from UN agencies (US$) of Afghanistan in 2003 to that in 2004?
Ensure brevity in your answer.  0.11. What is the ratio of the Aid flow from UN agencies (US$) in Bangladesh in 2003 to that in 2004?
Provide a short and direct response. 0.81. What is the ratio of the Aid flow from UN agencies (US$) of Timor-Leste in 2003 to that in 2004?
Make the answer very short. 1.42. What is the ratio of the Aid flow from UN agencies (US$) in Latin America(all income levels) in 2003 to that in 2005?
Make the answer very short. 0.69. What is the ratio of the Aid flow from UN agencies (US$) in Afghanistan in 2003 to that in 2005?
Make the answer very short. 0.09. What is the ratio of the Aid flow from UN agencies (US$) in Bangladesh in 2003 to that in 2005?
Provide a short and direct response. 0.99. What is the ratio of the Aid flow from UN agencies (US$) of Timor-Leste in 2003 to that in 2005?
Your response must be concise. 0.77. What is the ratio of the Aid flow from UN agencies (US$) of Latin America(all income levels) in 2003 to that in 2006?
Provide a succinct answer. 0.64. What is the ratio of the Aid flow from UN agencies (US$) in Afghanistan in 2003 to that in 2006?
Offer a very short reply. 0.08. What is the ratio of the Aid flow from UN agencies (US$) in Bangladesh in 2003 to that in 2006?
Your answer should be compact. 1.34. What is the ratio of the Aid flow from UN agencies (US$) in Timor-Leste in 2003 to that in 2006?
Give a very brief answer. 0.86. What is the ratio of the Aid flow from UN agencies (US$) in Latin America(all income levels) in 2003 to that in 2007?
Your response must be concise. 0.74. What is the ratio of the Aid flow from UN agencies (US$) in Afghanistan in 2003 to that in 2007?
Provide a short and direct response. 0.06. What is the ratio of the Aid flow from UN agencies (US$) of Bangladesh in 2003 to that in 2007?
Give a very brief answer. 0.97. What is the ratio of the Aid flow from UN agencies (US$) of Timor-Leste in 2003 to that in 2007?
Provide a succinct answer. 1.11. What is the ratio of the Aid flow from UN agencies (US$) in Latin America(all income levels) in 2004 to that in 2005?
Your response must be concise. 0.87. What is the ratio of the Aid flow from UN agencies (US$) of Afghanistan in 2004 to that in 2005?
Your response must be concise. 0.82. What is the ratio of the Aid flow from UN agencies (US$) in Bangladesh in 2004 to that in 2005?
Offer a terse response. 1.22. What is the ratio of the Aid flow from UN agencies (US$) of Timor-Leste in 2004 to that in 2005?
Your answer should be very brief. 0.54. What is the ratio of the Aid flow from UN agencies (US$) in Latin America(all income levels) in 2004 to that in 2006?
Provide a short and direct response. 0.81. What is the ratio of the Aid flow from UN agencies (US$) in Afghanistan in 2004 to that in 2006?
Provide a short and direct response. 0.77. What is the ratio of the Aid flow from UN agencies (US$) of Bangladesh in 2004 to that in 2006?
Your answer should be very brief. 1.66. What is the ratio of the Aid flow from UN agencies (US$) in Timor-Leste in 2004 to that in 2006?
Ensure brevity in your answer.  0.6. What is the ratio of the Aid flow from UN agencies (US$) in Latin America(all income levels) in 2004 to that in 2007?
Give a very brief answer. 0.93. What is the ratio of the Aid flow from UN agencies (US$) in Afghanistan in 2004 to that in 2007?
Ensure brevity in your answer.  0.51. What is the ratio of the Aid flow from UN agencies (US$) of Bangladesh in 2004 to that in 2007?
Give a very brief answer. 1.19. What is the ratio of the Aid flow from UN agencies (US$) of Timor-Leste in 2004 to that in 2007?
Provide a short and direct response. 0.78. What is the ratio of the Aid flow from UN agencies (US$) of Latin America(all income levels) in 2005 to that in 2006?
Ensure brevity in your answer.  0.93. What is the ratio of the Aid flow from UN agencies (US$) of Afghanistan in 2005 to that in 2006?
Your response must be concise. 0.93. What is the ratio of the Aid flow from UN agencies (US$) of Bangladesh in 2005 to that in 2006?
Your answer should be compact. 1.35. What is the ratio of the Aid flow from UN agencies (US$) in Timor-Leste in 2005 to that in 2006?
Offer a very short reply. 1.11. What is the ratio of the Aid flow from UN agencies (US$) in Latin America(all income levels) in 2005 to that in 2007?
Offer a very short reply. 1.07. What is the ratio of the Aid flow from UN agencies (US$) of Afghanistan in 2005 to that in 2007?
Provide a short and direct response. 0.62. What is the ratio of the Aid flow from UN agencies (US$) in Bangladesh in 2005 to that in 2007?
Give a very brief answer. 0.97. What is the ratio of the Aid flow from UN agencies (US$) in Timor-Leste in 2005 to that in 2007?
Offer a very short reply. 1.44. What is the ratio of the Aid flow from UN agencies (US$) of Latin America(all income levels) in 2006 to that in 2007?
Give a very brief answer. 1.15. What is the ratio of the Aid flow from UN agencies (US$) in Afghanistan in 2006 to that in 2007?
Keep it short and to the point. 0.67. What is the ratio of the Aid flow from UN agencies (US$) of Bangladesh in 2006 to that in 2007?
Offer a terse response. 0.72. What is the ratio of the Aid flow from UN agencies (US$) of Timor-Leste in 2006 to that in 2007?
Offer a terse response. 1.3. What is the difference between the highest and the second highest Aid flow from UN agencies (US$) of Latin America(all income levels)?
Your answer should be compact. 1.81e+06. What is the difference between the highest and the second highest Aid flow from UN agencies (US$) in Afghanistan?
Your response must be concise. 2.34e+06. What is the difference between the highest and the second highest Aid flow from UN agencies (US$) of Bangladesh?
Offer a very short reply. 3.17e+06. What is the difference between the highest and the lowest Aid flow from UN agencies (US$) of Latin America(all income levels)?
Your response must be concise. 1.62e+07. What is the difference between the highest and the lowest Aid flow from UN agencies (US$) in Afghanistan?
Provide a succinct answer. 1.07e+07. What is the difference between the highest and the lowest Aid flow from UN agencies (US$) in Bangladesh?
Your response must be concise. 7.76e+06. What is the difference between the highest and the lowest Aid flow from UN agencies (US$) in Timor-Leste?
Your response must be concise. 1.30e+06. 